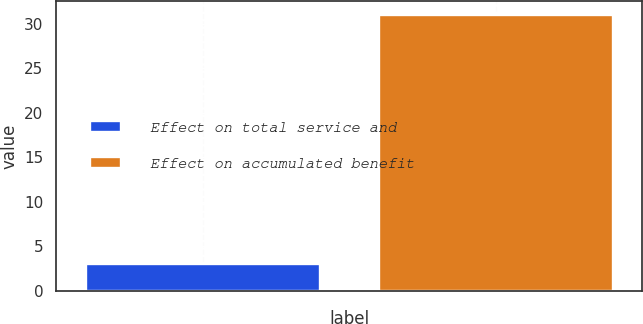Convert chart to OTSL. <chart><loc_0><loc_0><loc_500><loc_500><bar_chart><fcel>Effect on total service and<fcel>Effect on accumulated benefit<nl><fcel>3<fcel>31<nl></chart> 